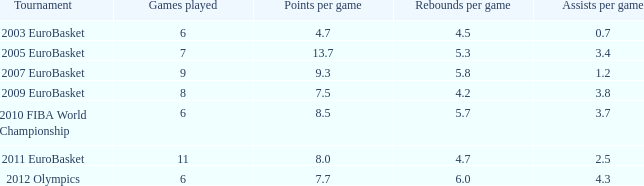How many games played have 4.7 as points per game? 6.0. 